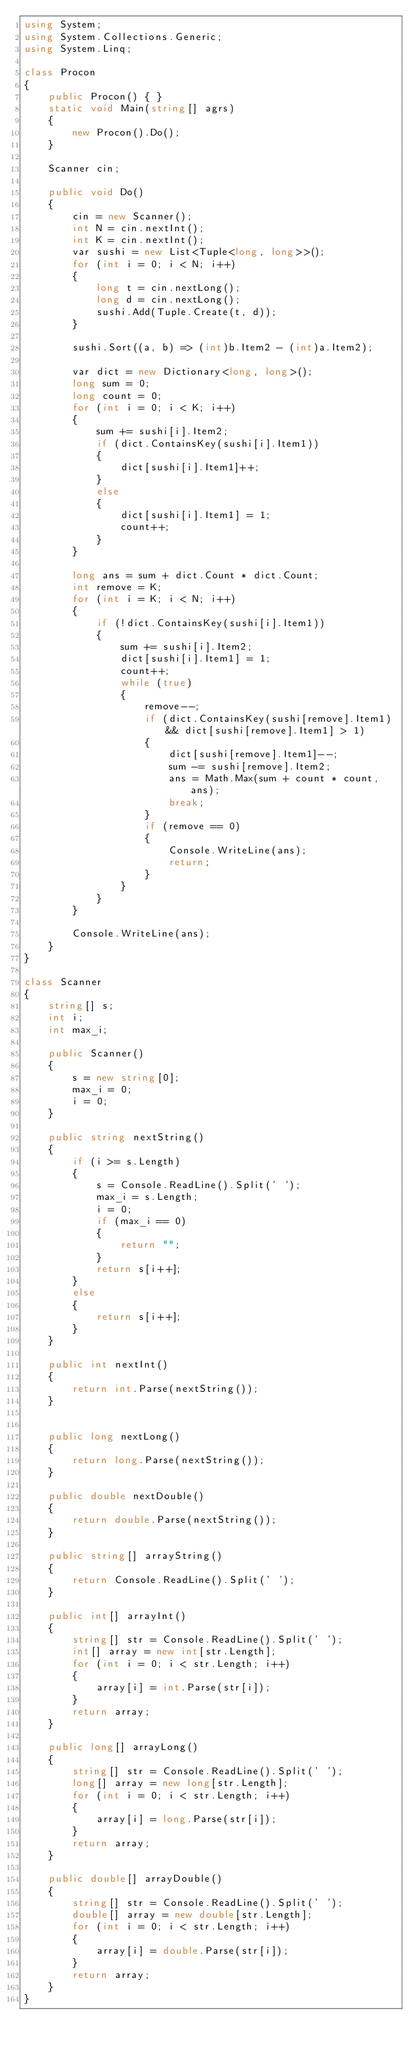Convert code to text. <code><loc_0><loc_0><loc_500><loc_500><_C#_>using System;
using System.Collections.Generic;
using System.Linq;

class Procon
{
    public Procon() { }
    static void Main(string[] agrs)
    {
        new Procon().Do();
    }

    Scanner cin;

    public void Do()
    {
        cin = new Scanner();
        int N = cin.nextInt();
        int K = cin.nextInt();
        var sushi = new List<Tuple<long, long>>();
        for (int i = 0; i < N; i++)
        {
            long t = cin.nextLong();
            long d = cin.nextLong();
            sushi.Add(Tuple.Create(t, d));
        }

        sushi.Sort((a, b) => (int)b.Item2 - (int)a.Item2);

        var dict = new Dictionary<long, long>();
        long sum = 0;
        long count = 0;
        for (int i = 0; i < K; i++)
        {
            sum += sushi[i].Item2;
            if (dict.ContainsKey(sushi[i].Item1))
            {
                dict[sushi[i].Item1]++;
            }
            else
            {
                dict[sushi[i].Item1] = 1;
                count++;
            }
        }

        long ans = sum + dict.Count * dict.Count;
        int remove = K;
        for (int i = K; i < N; i++)
        {
            if (!dict.ContainsKey(sushi[i].Item1))
            {
                sum += sushi[i].Item2;
                dict[sushi[i].Item1] = 1;
                count++;
                while (true)
                {
                    remove--;
                    if (dict.ContainsKey(sushi[remove].Item1) && dict[sushi[remove].Item1] > 1)
                    {
                        dict[sushi[remove].Item1]--;
                        sum -= sushi[remove].Item2;
                        ans = Math.Max(sum + count * count, ans);
                        break;
                    }
                    if (remove == 0)
                    {
                        Console.WriteLine(ans);
                        return;
                    }
                }
            }
        }

        Console.WriteLine(ans);
    }
}

class Scanner
{
    string[] s;
    int i;
    int max_i;

    public Scanner()
    {
        s = new string[0];
        max_i = 0;
        i = 0;
    }

    public string nextString()
    {
        if (i >= s.Length)
        {
            s = Console.ReadLine().Split(' ');
            max_i = s.Length;
            i = 0;
            if (max_i == 0)
            {
                return "";
            }
            return s[i++];
        }
        else
        {
            return s[i++];
        }
    }

    public int nextInt()
    {
        return int.Parse(nextString());
    }


    public long nextLong()
    {
        return long.Parse(nextString());
    }

    public double nextDouble()
    {
        return double.Parse(nextString());
    }

    public string[] arrayString()
    {
        return Console.ReadLine().Split(' ');
    }

    public int[] arrayInt()
    {
        string[] str = Console.ReadLine().Split(' ');
        int[] array = new int[str.Length];
        for (int i = 0; i < str.Length; i++)
        {
            array[i] = int.Parse(str[i]);
        }
        return array;
    }

    public long[] arrayLong()
    {
        string[] str = Console.ReadLine().Split(' ');
        long[] array = new long[str.Length];
        for (int i = 0; i < str.Length; i++)
        {
            array[i] = long.Parse(str[i]);
        }
        return array;
    }

    public double[] arrayDouble()
    {
        string[] str = Console.ReadLine().Split(' ');
        double[] array = new double[str.Length];
        for (int i = 0; i < str.Length; i++)
        {
            array[i] = double.Parse(str[i]);
        }
        return array;
    }
}
</code> 